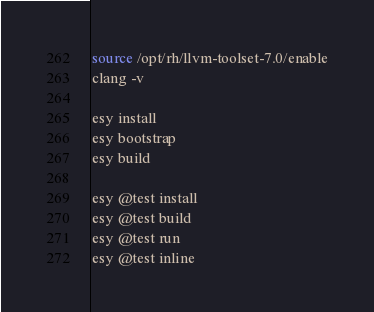<code> <loc_0><loc_0><loc_500><loc_500><_Bash_>source /opt/rh/llvm-toolset-7.0/enable
clang -v

esy install
esy bootstrap
esy build

esy @test install
esy @test build
esy @test run
esy @test inline
</code> 